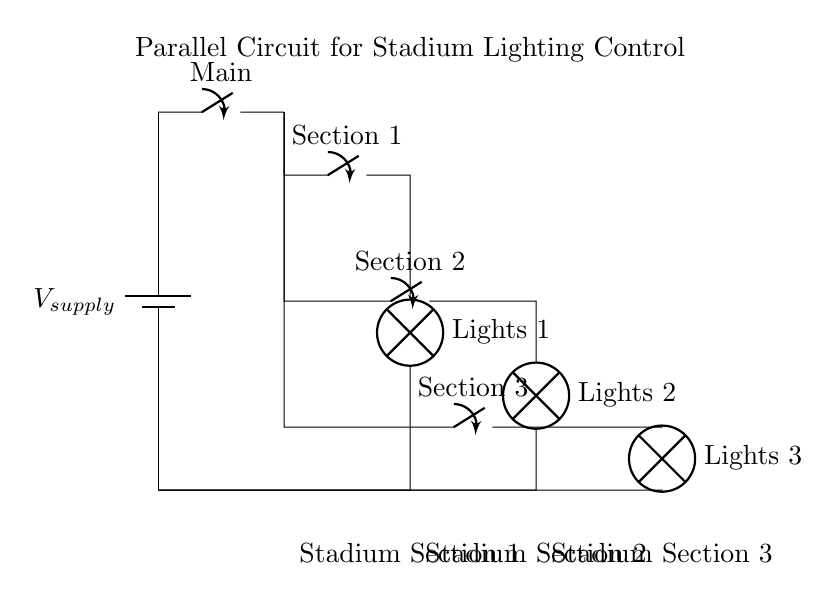What is the main component providing power to the circuit? The main component providing power is the battery, which is represented in the circuit. It is positioned at the left side of the diagram.
Answer: Battery How many sections are controlled by switches in this circuit? The diagram shows three individual switches, each controlling a different section of the stadium lighting. Each switch corresponds to a specific section of lights.
Answer: Three What is the role of the main switch in the circuit? The main switch controls the entire circuit, allowing or stopping the flow of electricity to all sections at once. Its position affects all subsequent switches and lamps.
Answer: Control If Section 2 is turned off, how many sections will still operate? With Section 2 turned off, Sections 1 and 3 will still operate because they are independent due to the parallel configuration. This configuration allows sections to operate independently of each other.
Answer: Two What type of circuit is illustrated in this diagram? The circuit is a parallel circuit, as indicated by the arrangement where multiple paths exist for current flow, allowing different sections to be powered independently.
Answer: Parallel Which section is furthest to the right in the diagram? Section 3 is furthest to the right in the diagram; it is located at the bottom right area of the circuit layout.
Answer: Section 3 